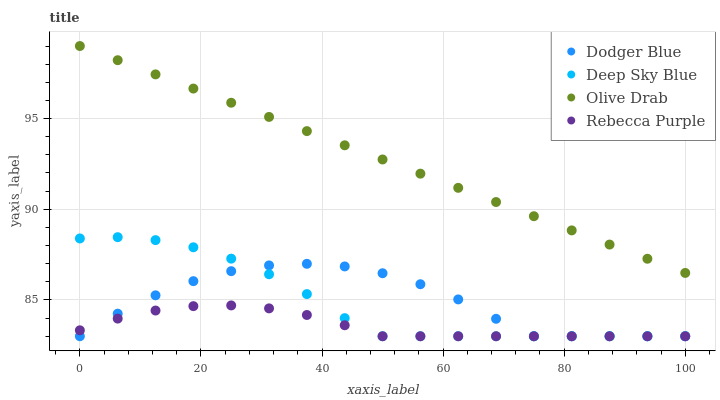Does Rebecca Purple have the minimum area under the curve?
Answer yes or no. Yes. Does Olive Drab have the maximum area under the curve?
Answer yes or no. Yes. Does Deep Sky Blue have the minimum area under the curve?
Answer yes or no. No. Does Deep Sky Blue have the maximum area under the curve?
Answer yes or no. No. Is Olive Drab the smoothest?
Answer yes or no. Yes. Is Dodger Blue the roughest?
Answer yes or no. Yes. Is Deep Sky Blue the smoothest?
Answer yes or no. No. Is Deep Sky Blue the roughest?
Answer yes or no. No. Does Dodger Blue have the lowest value?
Answer yes or no. Yes. Does Olive Drab have the lowest value?
Answer yes or no. No. Does Olive Drab have the highest value?
Answer yes or no. Yes. Does Deep Sky Blue have the highest value?
Answer yes or no. No. Is Rebecca Purple less than Olive Drab?
Answer yes or no. Yes. Is Olive Drab greater than Deep Sky Blue?
Answer yes or no. Yes. Does Rebecca Purple intersect Deep Sky Blue?
Answer yes or no. Yes. Is Rebecca Purple less than Deep Sky Blue?
Answer yes or no. No. Is Rebecca Purple greater than Deep Sky Blue?
Answer yes or no. No. Does Rebecca Purple intersect Olive Drab?
Answer yes or no. No. 